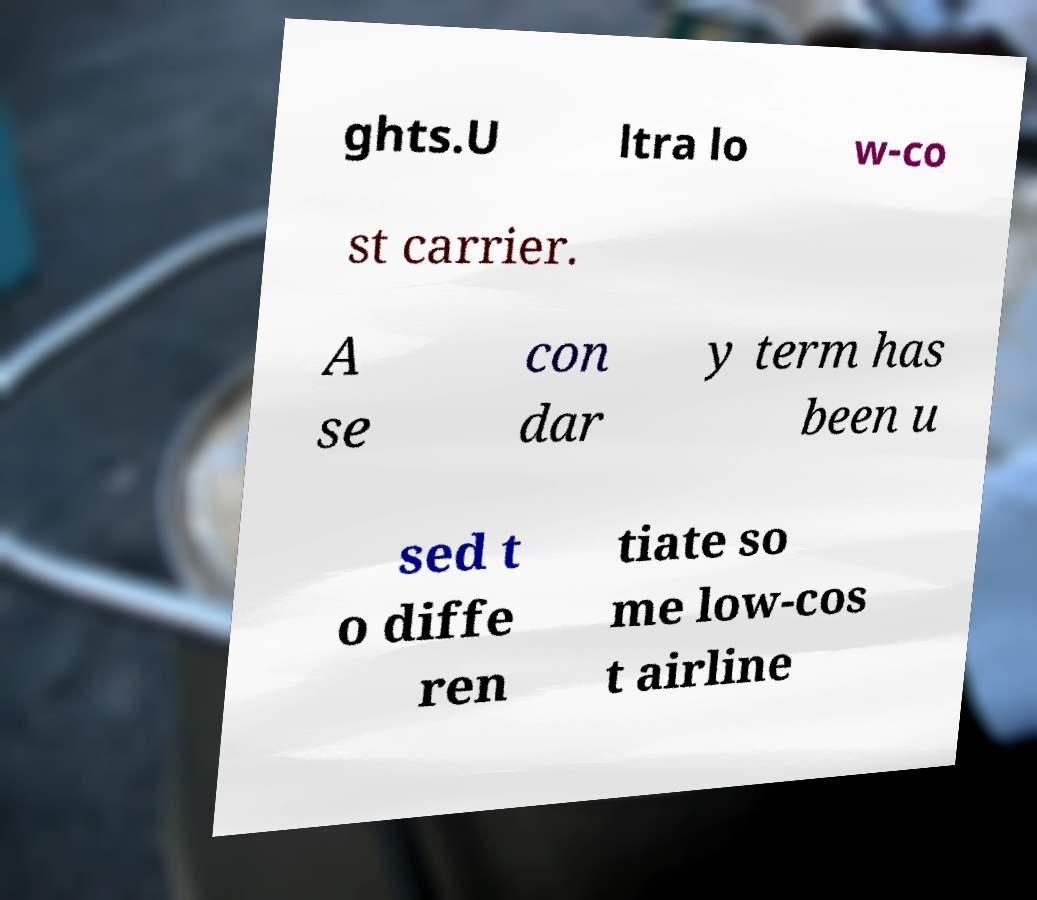Can you read and provide the text displayed in the image?This photo seems to have some interesting text. Can you extract and type it out for me? ghts.U ltra lo w-co st carrier. A se con dar y term has been u sed t o diffe ren tiate so me low-cos t airline 